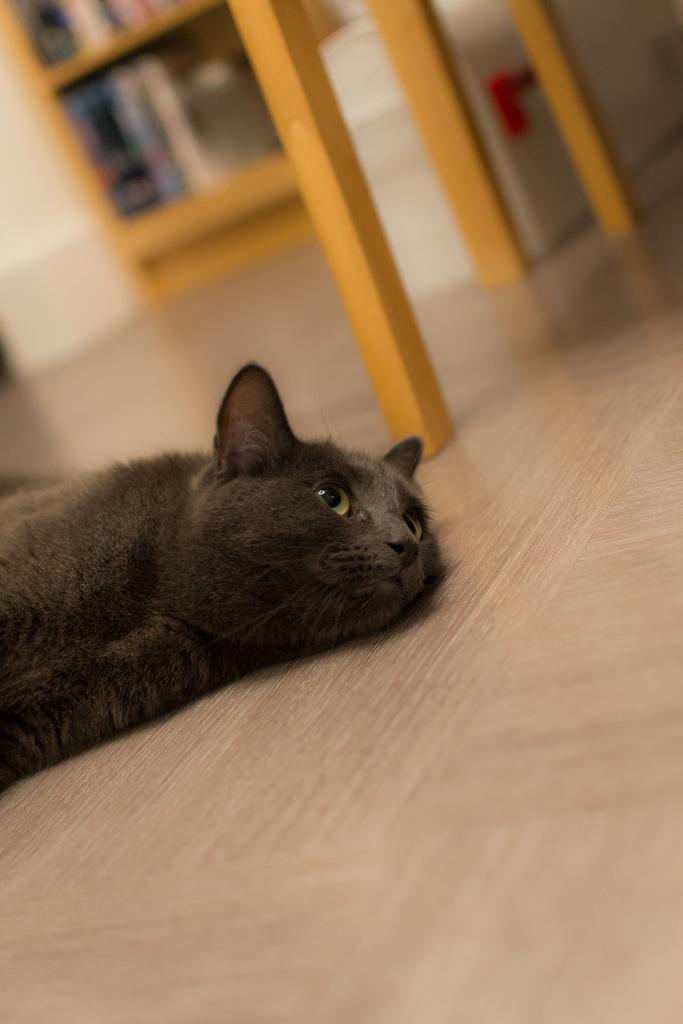In one or two sentences, can you explain what this image depicts? In this image we can see one animal on the floor, beside there are few wooden objects. 